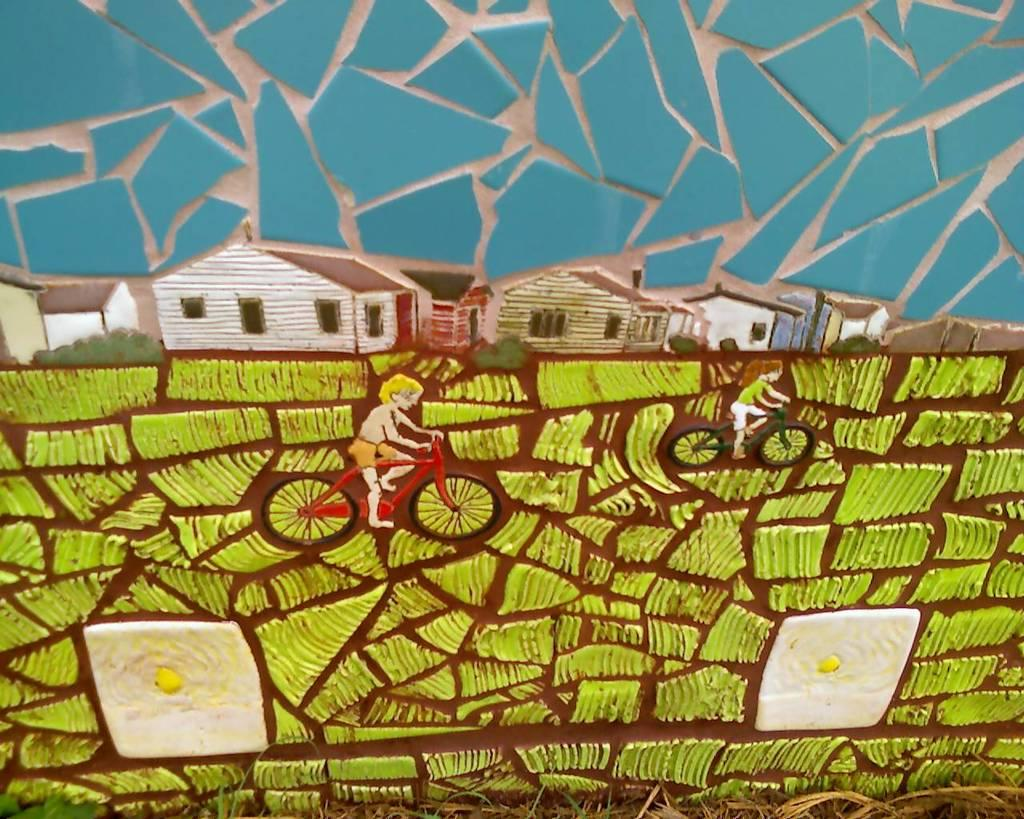What is the main subject of the image? The image contains an art piece. What does the art piece depict? The art piece depicts houses. Are there any people in the art piece? Yes, there are two people in the art piece. What are the two people doing in the art piece? The two people are sitting on bicycles. How many cherries can be seen in the image? There are no cherries present in the image. What type of rings are the two people wearing in the image? There are no rings visible on the two people in the image. 